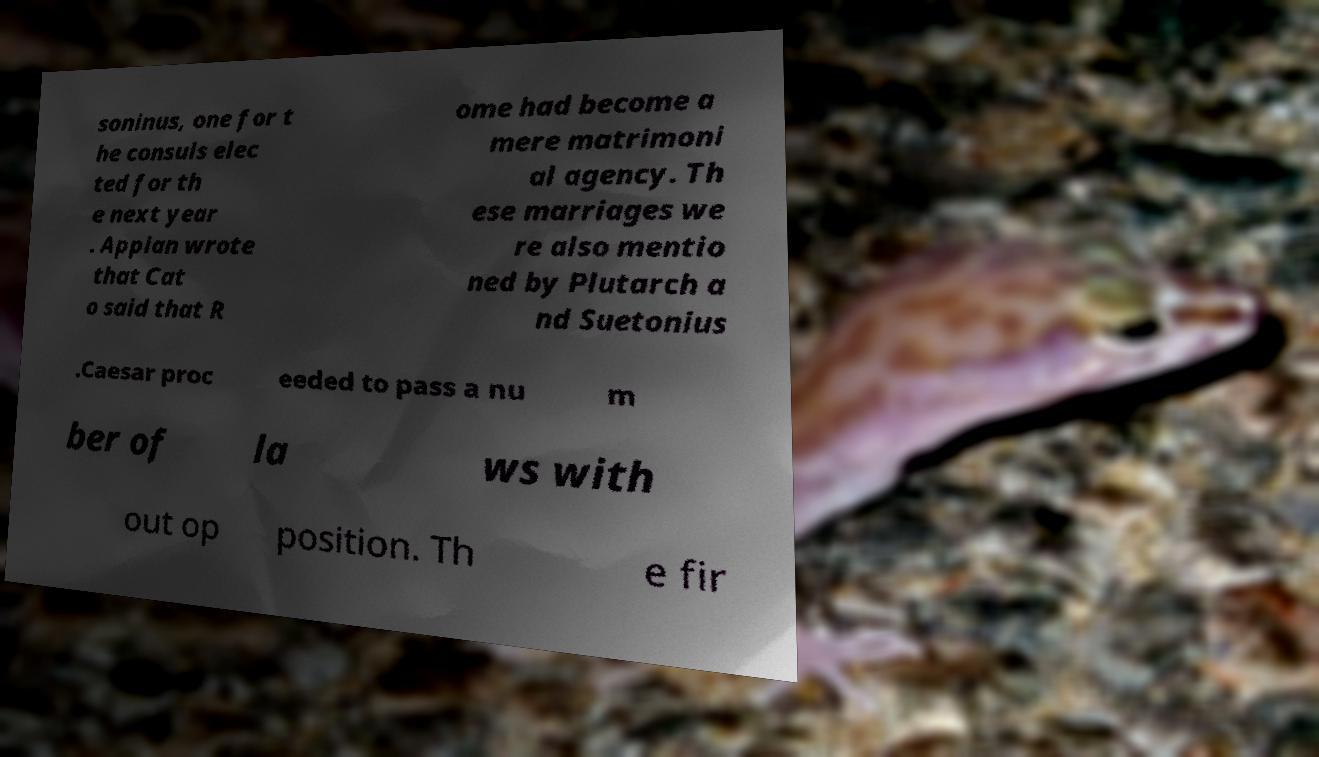Can you read and provide the text displayed in the image?This photo seems to have some interesting text. Can you extract and type it out for me? soninus, one for t he consuls elec ted for th e next year . Appian wrote that Cat o said that R ome had become a mere matrimoni al agency. Th ese marriages we re also mentio ned by Plutarch a nd Suetonius .Caesar proc eeded to pass a nu m ber of la ws with out op position. Th e fir 